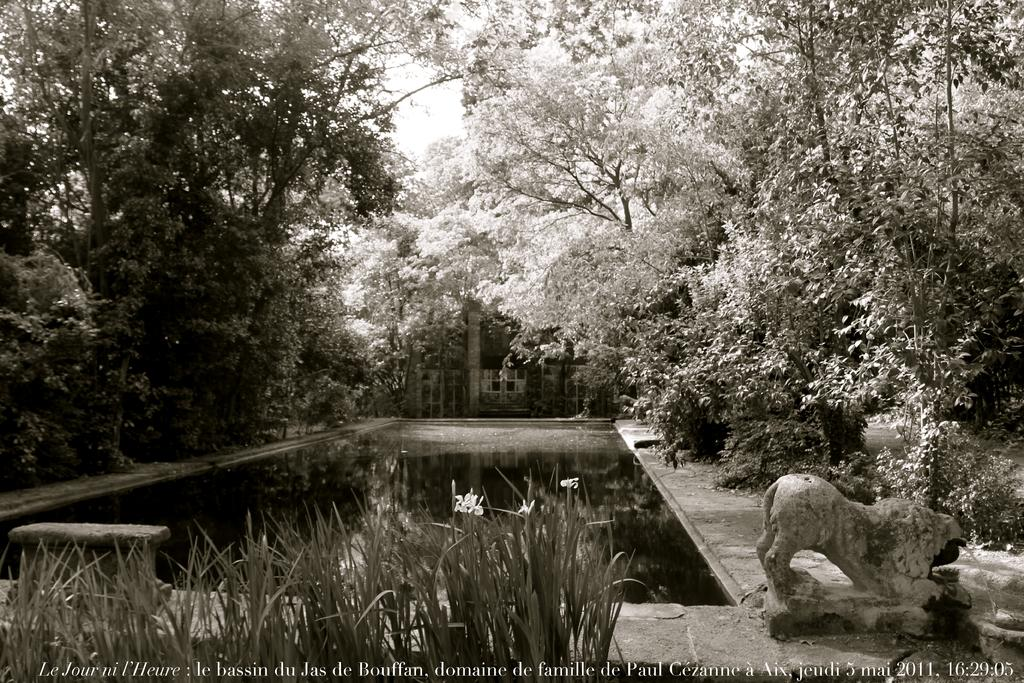What is present in the image that is not a solid object? Water is visible in the image, which is not a solid object. What type of vegetation can be seen in the image? There are plants and trees in the image. What structure is visible in the background of the image? There is a house in the background of the image. What is visible in the sky in the image? The sky is visible in the background of the image. What type of cloth is draped over the trees in the image? There is no cloth draped over the trees in the image; it is in black and white, and the trees are visible without any cloth. What sense is being stimulated by the image? The image is visual, so it primarily stimulates the sense of sight. 